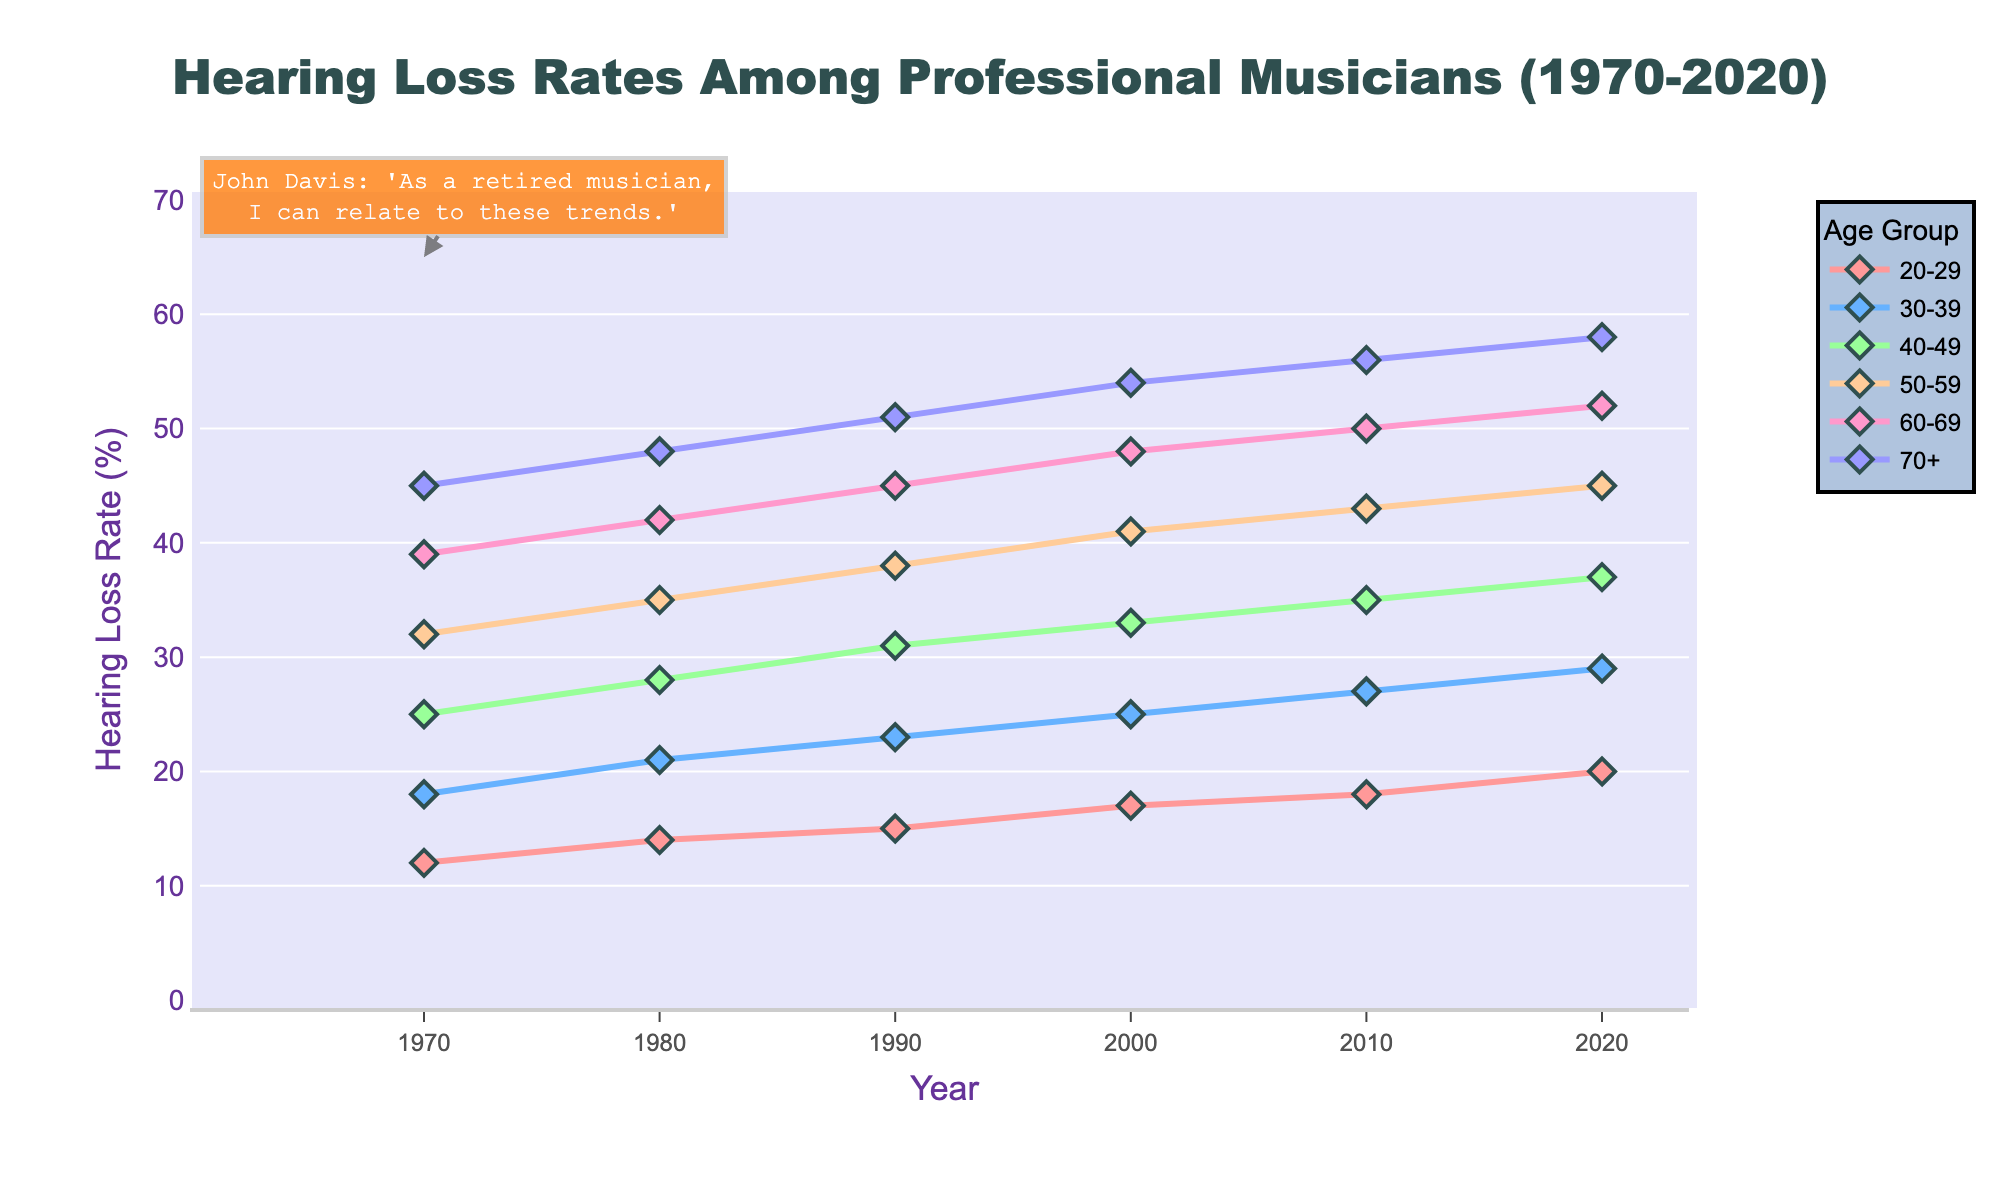What's the highest hearing loss rate observed for the 60-69 age group over the years? Identify the maximum value in the 60-69 age group series from 1970 to 2020. The values are 39%, 42%, 45%, 48%, 50%, and 52%. Hence the highest is 52%.
Answer: 52% Between which years does the 40-49 age group see the greatest increase in hearing loss rate? Calculate the difference between consecutive data points for the 40-49 age group. The differences are: 3% (1970-1980), 3% (1980-1990), 2% (1990-2000), 2% (2000-2010), 2% (2010-2020). The greatest increase occurs between 1970 and 1980.
Answer: 1970-1980 Compare the hearing loss rates of the 20-29 age group and the 30-39 age group in 2010. Which one is higher? Look at the rates for both age groups in 2010. The 20-29 age group has an 18% rate, and the 30-39 age group has a 27% rate. The 30-39 age group rate is higher.
Answer: 30-39 age group Which age group had the most notable increase between the years 1970 and 2020? Calculate the difference between the values from 1970 to 2020 for each age group and compare them. Increases are: 8% (20-29), 11% (30-39), 12% (40-49), 13% (50-59), 13% (60-69), 13% (70+). The most notable increases are in 50-69 and 70+.
Answer: 50-69 and 70+ Which line is colored in shades of blue? Observe the colors associated with each age group line. The line for the 30-39 age group is in blue.
Answer: 30-39 age group What is the average hearing loss rate for the 50-59 age group from the years presented? Sum the values for the 50-59 age group (32% + 35% + 38% + 41% + 43% + 45%) = 234%. To find the average, 234% / 6 = 39%.
Answer: 39% Between which two age groups is there the least difference in hearing loss rates in 2020? Check the 2020 values for each age group and calculate the differences between every pair. The smallest difference in 2020 is between the 60-69 group (52%) and the 70+ group (58%), which is a difference of 6%.
Answer: 60-69 and 70+ During which decade did the 20-29 age group see its least change in hearing loss rate? Calculate the changes over each decade for the 20-29 group: 2% (1970-80), 1% (1980-90), 2% (1990-2000), 1% (2000-10), 2% (2010-2020). The least change is 1%, observed in two decades, 1980-1990 and 2000-2010.
Answer: 1980-1990 and 2000-2010 